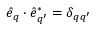Convert formula to latex. <formula><loc_0><loc_0><loc_500><loc_500>\hat { e } _ { q } \cdot \hat { e } _ { q ^ { \prime } } ^ { * } = \delta _ { q q ^ { \prime } }</formula> 